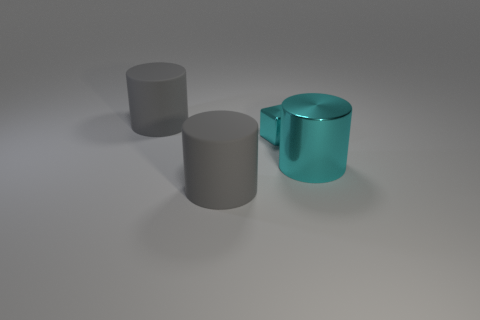Add 1 cyan things. How many objects exist? 5 Subtract 1 cubes. How many cubes are left? 0 Add 1 matte objects. How many matte objects are left? 3 Add 4 large rubber cylinders. How many large rubber cylinders exist? 6 Subtract all cyan cylinders. How many cylinders are left? 2 Subtract all big cyan cylinders. How many cylinders are left? 2 Subtract 0 purple balls. How many objects are left? 4 Subtract all cylinders. How many objects are left? 1 Subtract all yellow blocks. Subtract all gray balls. How many blocks are left? 1 Subtract all cyan cubes. How many brown cylinders are left? 0 